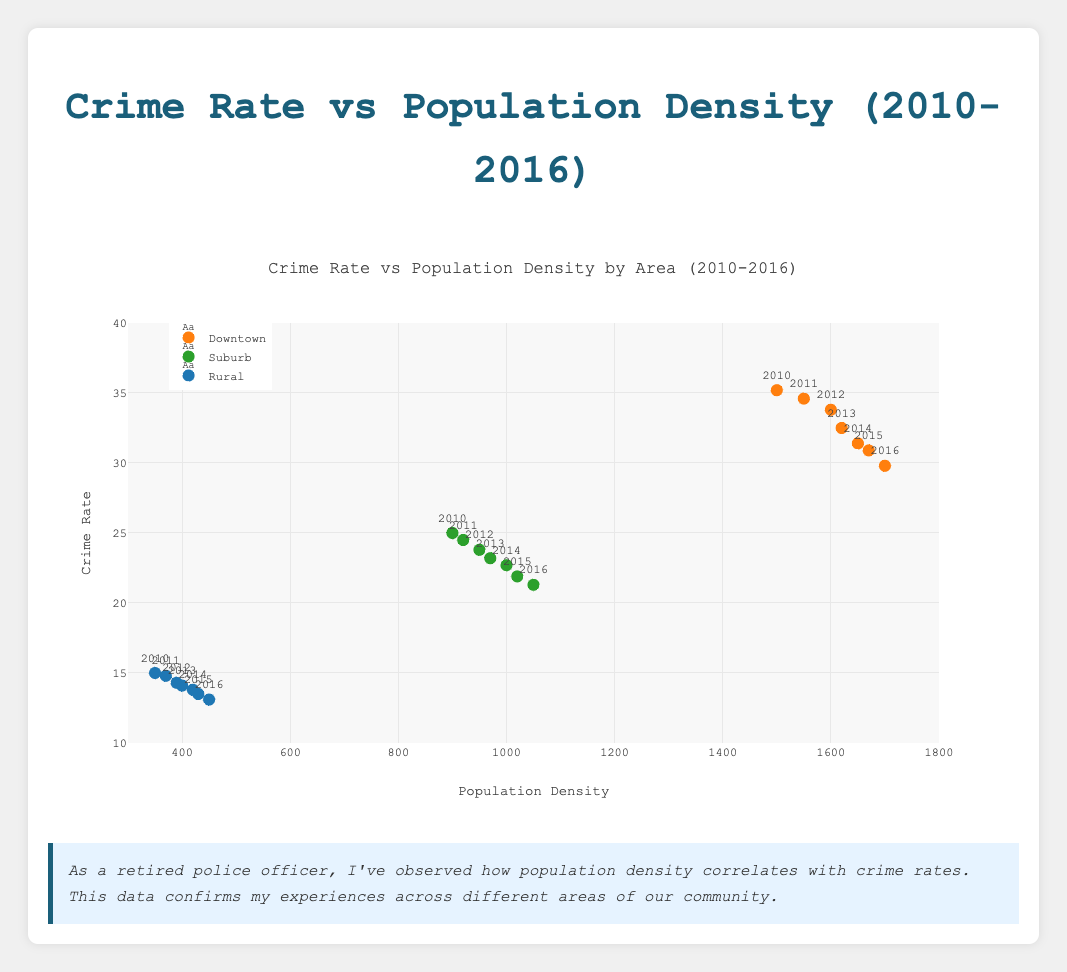What is the trend in crime rate for Downtown from 2010 to 2016? Observing the data points for Downtown shows that as years progress (2010 to 2016), the crime rate generally decreases. For example, it goes from 35.2 in 2010 to 29.8 in 2016.
Answer: Decreasing Comparing Suburb and Rural areas, which has a higher overall crime rate? Looking at the data points for both Suburb and Rural areas, it's apparent that the crime rates in the Suburb are consistently higher than in the Rural areas for all years from 2010 to 2016. For instance, in 2016, Suburb has a crime rate of 21.3 while Rural has 13.1.
Answer: Suburb What is the average crime rate in Rural areas from 2010 to 2016? To find the average crime rate in Rural areas, sum up the crime rates from 2010 to 2016 (15.0, 14.8, 14.3, 14.1, 13.8, 13.5, 13.1) and then divide by the number of years (7). This calculation gives (15.0 + 14.8 + 14.3 + 14.1 + 13.8 + 13.5 + 13.1) / 7 = 14.09.
Answer: 14.09 Which area saw the largest decrease in crime rate from 2010 to 2016? By calculating the difference between the crime rates of 2010 and 2016 for each area, we get: Downtown (35.2 - 29.8 = 5.4), Suburb (25.0 - 21.3 = 3.7), and Rural (15.0 - 13.1 = 1.9). Downtown has the largest decrease of 5.4.
Answer: Downtown By how much did the population density increase in Suburb from 2010 to 2016? Subtract the population density of 2010 from that of 2016 in Suburb: 1050 - 900 = 150.
Answer: 150 What is the relationship between population density and crime rate in Downtown? From the scatter plot, as population density in Downtown increases from 1500 to 1700, there is a noticeable decrease in crime rate from 35.2 to 29.8. This suggests a negative correlation between population density and crime rate in Downtown.
Answer: Negative correlation Which area has the lowest crime rate in 2014 and what is it? Observing the 2014 data points, Rural has the lowest crime rate at 13.8.
Answer: Rural, 13.8 Are there any years where the crime rate in Suburb increased compared to the previous year? Reviewing the Suburb data points from 2010 to 2016 shows no year where the crime rate increased compared to the previous year; it consistently decreases.
Answer: No How does the crime rate trend in Rural compare to the other areas? All areas (Downtown, Suburb, Rural) show a general decrease in crime rates from 2010 to 2016, but Rural starts with the lowest crime rate and decreases less rapidly compared to Downtown and Suburb.
Answer: Gradual decrease 